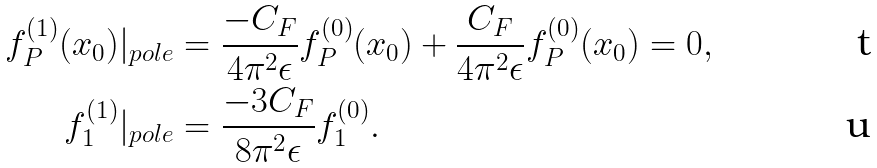Convert formula to latex. <formula><loc_0><loc_0><loc_500><loc_500>f _ { P } ^ { ( 1 ) } ( x _ { 0 } ) | _ { p o l e } & = \frac { - C _ { F } } { 4 \pi ^ { 2 } \epsilon } f _ { P } ^ { ( 0 ) } ( x _ { 0 } ) + \frac { C _ { F } } { 4 \pi ^ { 2 } \epsilon } f _ { P } ^ { ( 0 ) } ( x _ { 0 } ) = 0 , \\ f _ { 1 } ^ { ( 1 ) } | _ { p o l e } & = \frac { - 3 C _ { F } } { 8 \pi ^ { 2 } \epsilon } f _ { 1 } ^ { ( 0 ) } .</formula> 